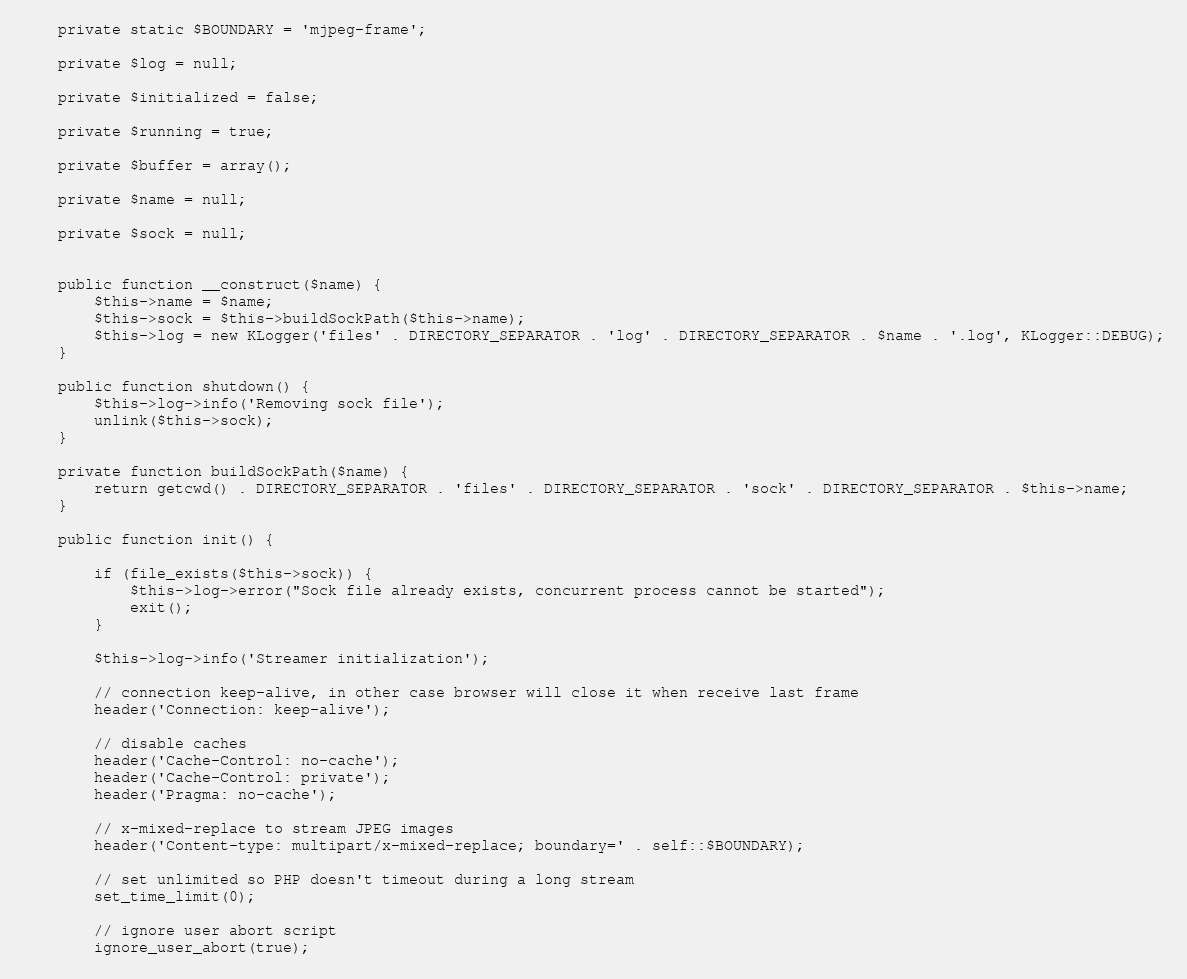Convert code to text. <code><loc_0><loc_0><loc_500><loc_500><_PHP_>	private static $BOUNDARY = 'mjpeg-frame';

	private $log = null;

	private $initialized = false;

	private $running = true;

	private $buffer = array();

	private $name = null;

	private $sock = null;


	public function __construct($name) {
		$this->name = $name;
		$this->sock = $this->buildSockPath($this->name);
		$this->log = new KLogger('files' . DIRECTORY_SEPARATOR . 'log' . DIRECTORY_SEPARATOR . $name . '.log', KLogger::DEBUG);
	}

	public function shutdown() {
		$this->log->info('Removing sock file');
		unlink($this->sock);
	}

	private function buildSockPath($name) {
		return getcwd() . DIRECTORY_SEPARATOR . 'files' . DIRECTORY_SEPARATOR . 'sock' . DIRECTORY_SEPARATOR . $this->name;
	}

	public function init() {

		if (file_exists($this->sock)) {
			$this->log->error("Sock file already exists, concurrent process cannot be started");
			exit();
		}

		$this->log->info('Streamer initialization');

		// connection keep-alive, in other case browser will close it when receive last frame
		header('Connection: keep-alive');

		// disable caches
		header('Cache-Control: no-cache');
		header('Cache-Control: private');
		header('Pragma: no-cache');

		// x-mixed-replace to stream JPEG images
		header('Content-type: multipart/x-mixed-replace; boundary=' . self::$BOUNDARY);

		// set unlimited so PHP doesn't timeout during a long stream
		set_time_limit(0);

		// ignore user abort script
		ignore_user_abort(true);
</code> 